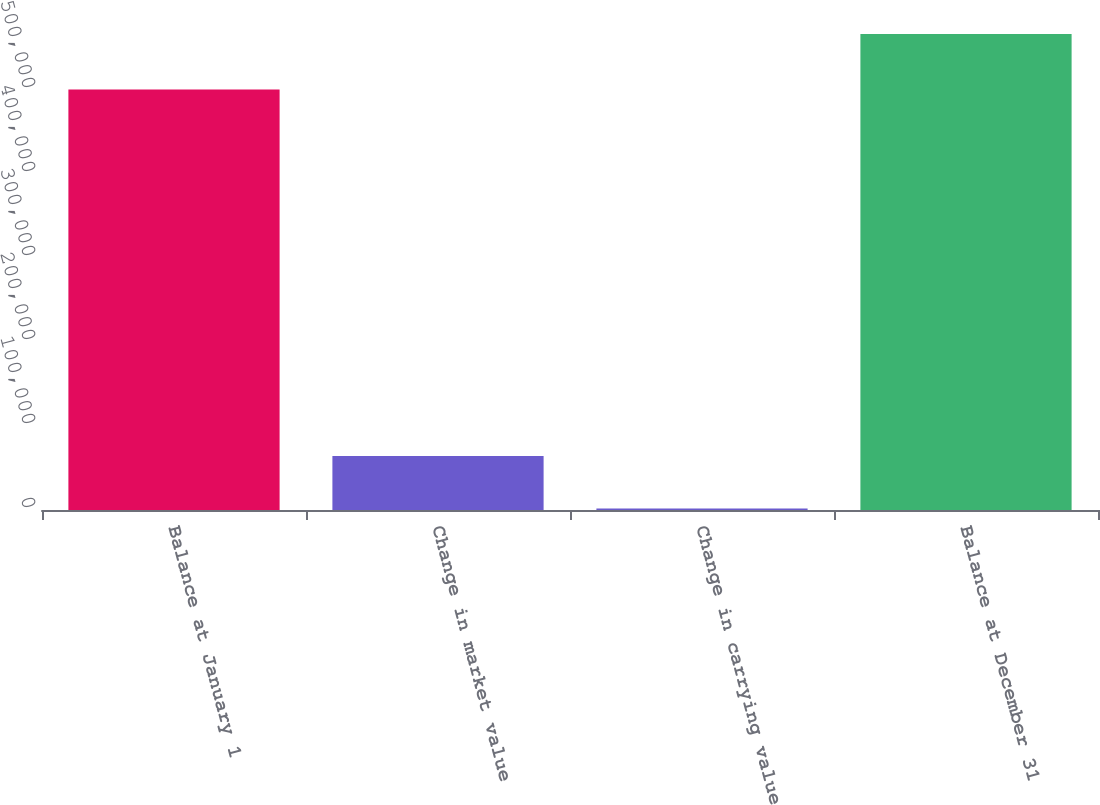Convert chart to OTSL. <chart><loc_0><loc_0><loc_500><loc_500><bar_chart><fcel>Balance at January 1<fcel>Change in market value<fcel>Change in carrying value<fcel>Balance at December 31<nl><fcel>500733<fcel>64378<fcel>1672<fcel>566783<nl></chart> 